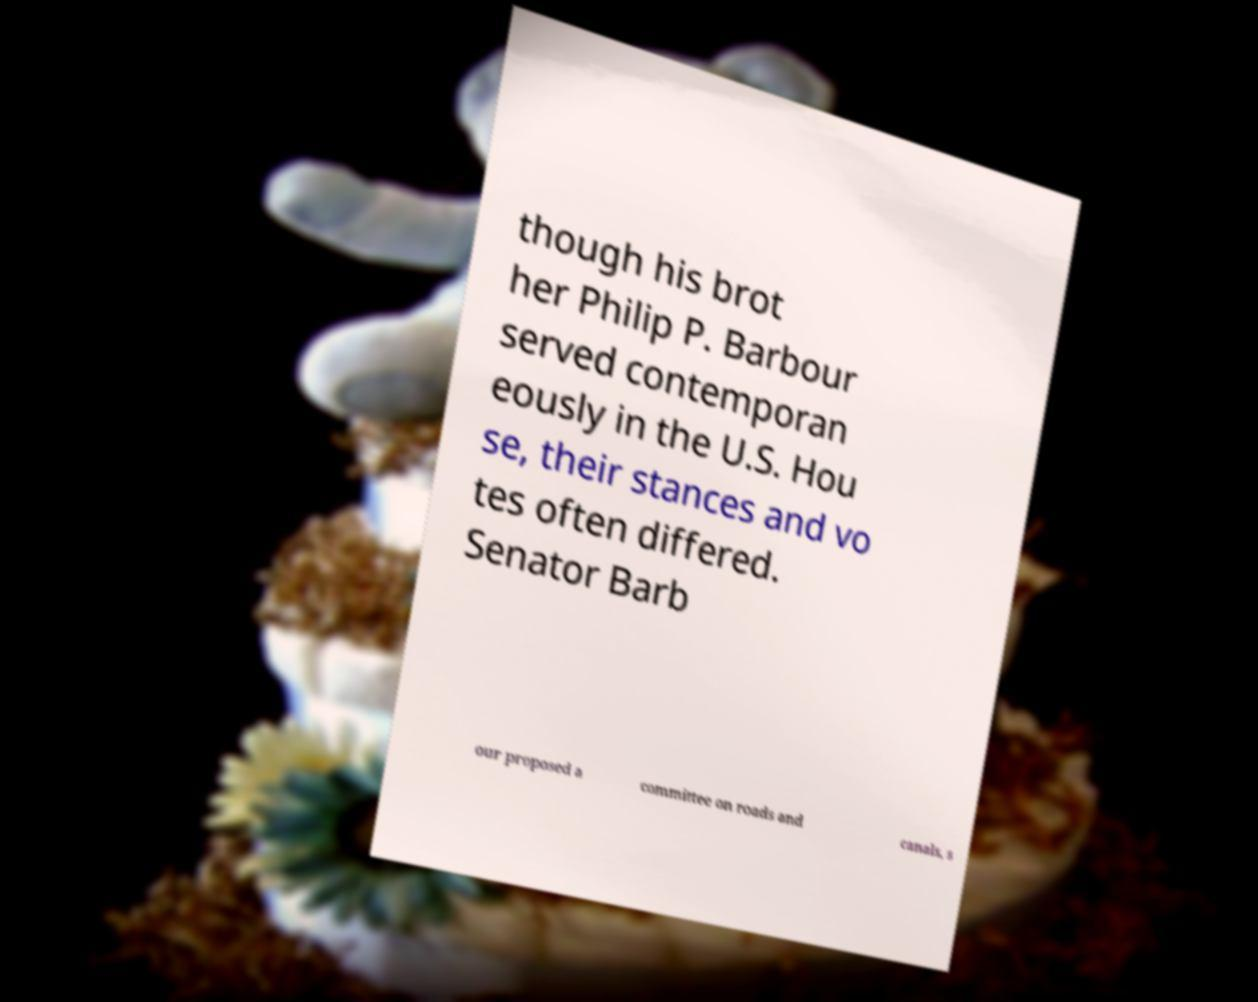What messages or text are displayed in this image? I need them in a readable, typed format. though his brot her Philip P. Barbour served contemporan eously in the U.S. Hou se, their stances and vo tes often differed. Senator Barb our proposed a committee on roads and canals, s 